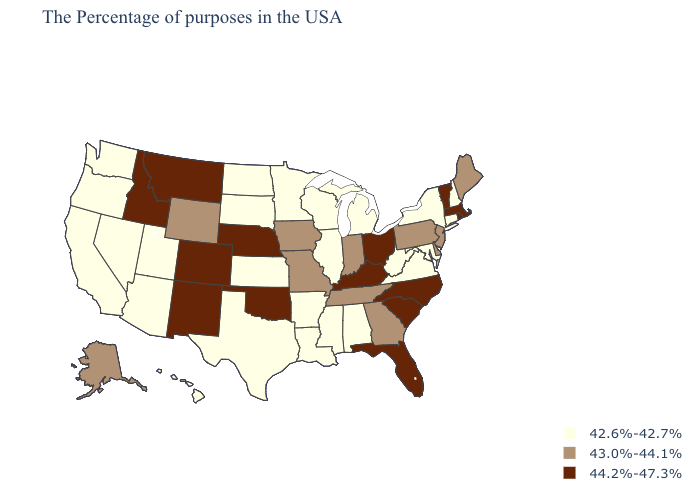What is the highest value in states that border Oregon?
Concise answer only. 44.2%-47.3%. What is the value of Hawaii?
Concise answer only. 42.6%-42.7%. Does Florida have a lower value than New York?
Answer briefly. No. What is the highest value in states that border Ohio?
Answer briefly. 44.2%-47.3%. Does Utah have the lowest value in the USA?
Keep it brief. Yes. What is the value of Florida?
Concise answer only. 44.2%-47.3%. Which states have the lowest value in the USA?
Quick response, please. New Hampshire, Connecticut, New York, Maryland, Virginia, West Virginia, Michigan, Alabama, Wisconsin, Illinois, Mississippi, Louisiana, Arkansas, Minnesota, Kansas, Texas, South Dakota, North Dakota, Utah, Arizona, Nevada, California, Washington, Oregon, Hawaii. Is the legend a continuous bar?
Short answer required. No. Is the legend a continuous bar?
Give a very brief answer. No. Which states hav the highest value in the West?
Concise answer only. Colorado, New Mexico, Montana, Idaho. What is the value of North Dakota?
Short answer required. 42.6%-42.7%. Does Tennessee have the same value as Georgia?
Short answer required. Yes. Name the states that have a value in the range 43.0%-44.1%?
Short answer required. Maine, New Jersey, Delaware, Pennsylvania, Georgia, Indiana, Tennessee, Missouri, Iowa, Wyoming, Alaska. Name the states that have a value in the range 43.0%-44.1%?
Keep it brief. Maine, New Jersey, Delaware, Pennsylvania, Georgia, Indiana, Tennessee, Missouri, Iowa, Wyoming, Alaska. How many symbols are there in the legend?
Answer briefly. 3. 